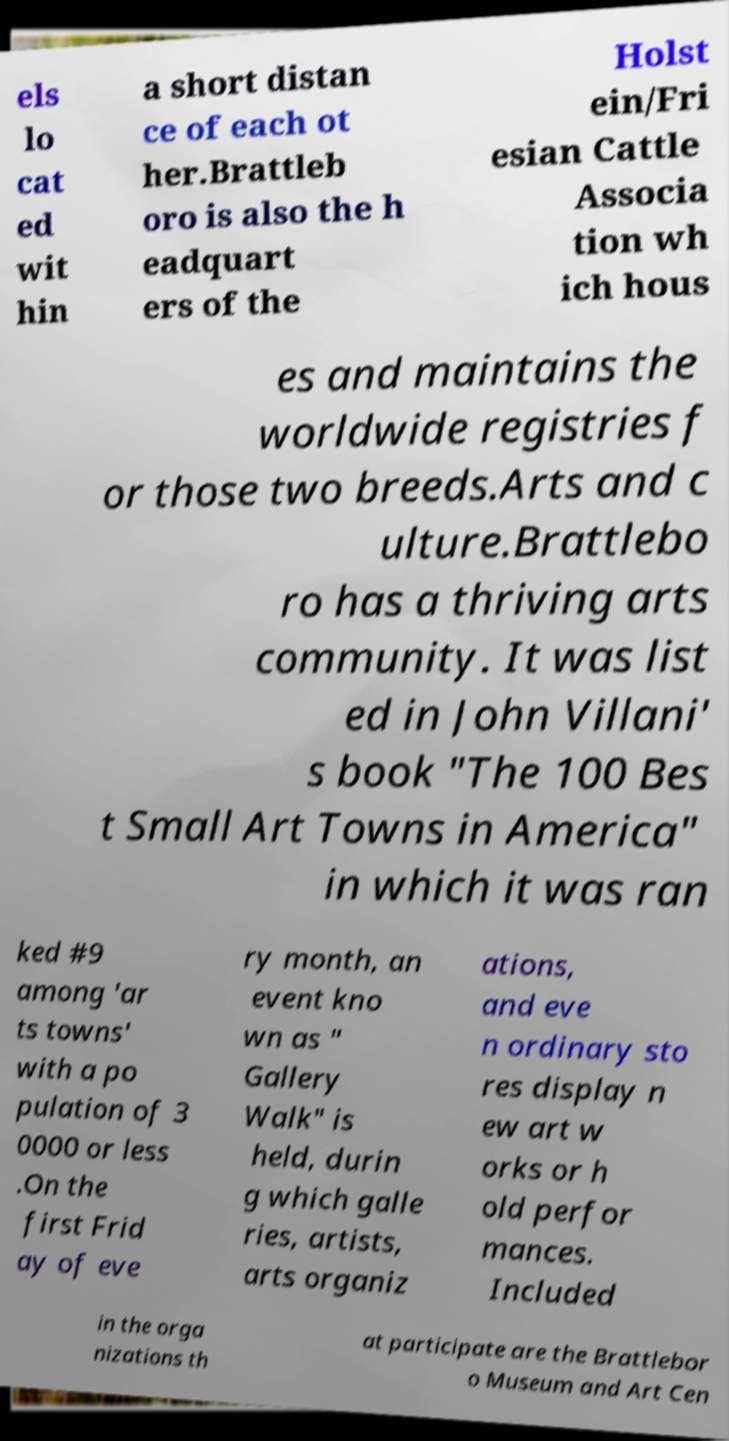Could you extract and type out the text from this image? els lo cat ed wit hin a short distan ce of each ot her.Brattleb oro is also the h eadquart ers of the Holst ein/Fri esian Cattle Associa tion wh ich hous es and maintains the worldwide registries f or those two breeds.Arts and c ulture.Brattlebo ro has a thriving arts community. It was list ed in John Villani' s book "The 100 Bes t Small Art Towns in America" in which it was ran ked #9 among 'ar ts towns' with a po pulation of 3 0000 or less .On the first Frid ay of eve ry month, an event kno wn as " Gallery Walk" is held, durin g which galle ries, artists, arts organiz ations, and eve n ordinary sto res display n ew art w orks or h old perfor mances. Included in the orga nizations th at participate are the Brattlebor o Museum and Art Cen 